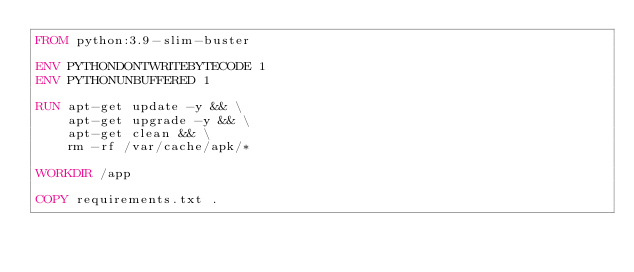Convert code to text. <code><loc_0><loc_0><loc_500><loc_500><_Dockerfile_>FROM python:3.9-slim-buster

ENV PYTHONDONTWRITEBYTECODE 1
ENV PYTHONUNBUFFERED 1

RUN apt-get update -y && \
    apt-get upgrade -y && \
    apt-get clean && \
    rm -rf /var/cache/apk/*

WORKDIR /app

COPY requirements.txt .
</code> 